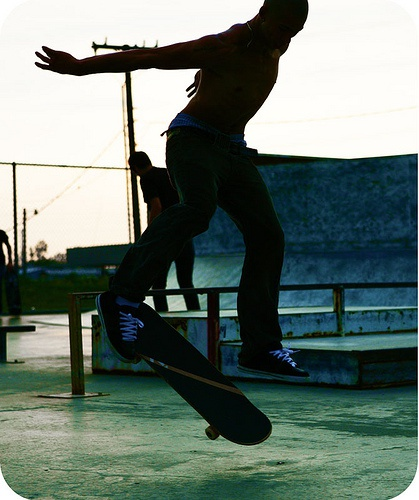Describe the objects in this image and their specific colors. I can see people in white, black, navy, and teal tones, skateboard in white, black, and teal tones, and people in white, black, teal, and darkgreen tones in this image. 